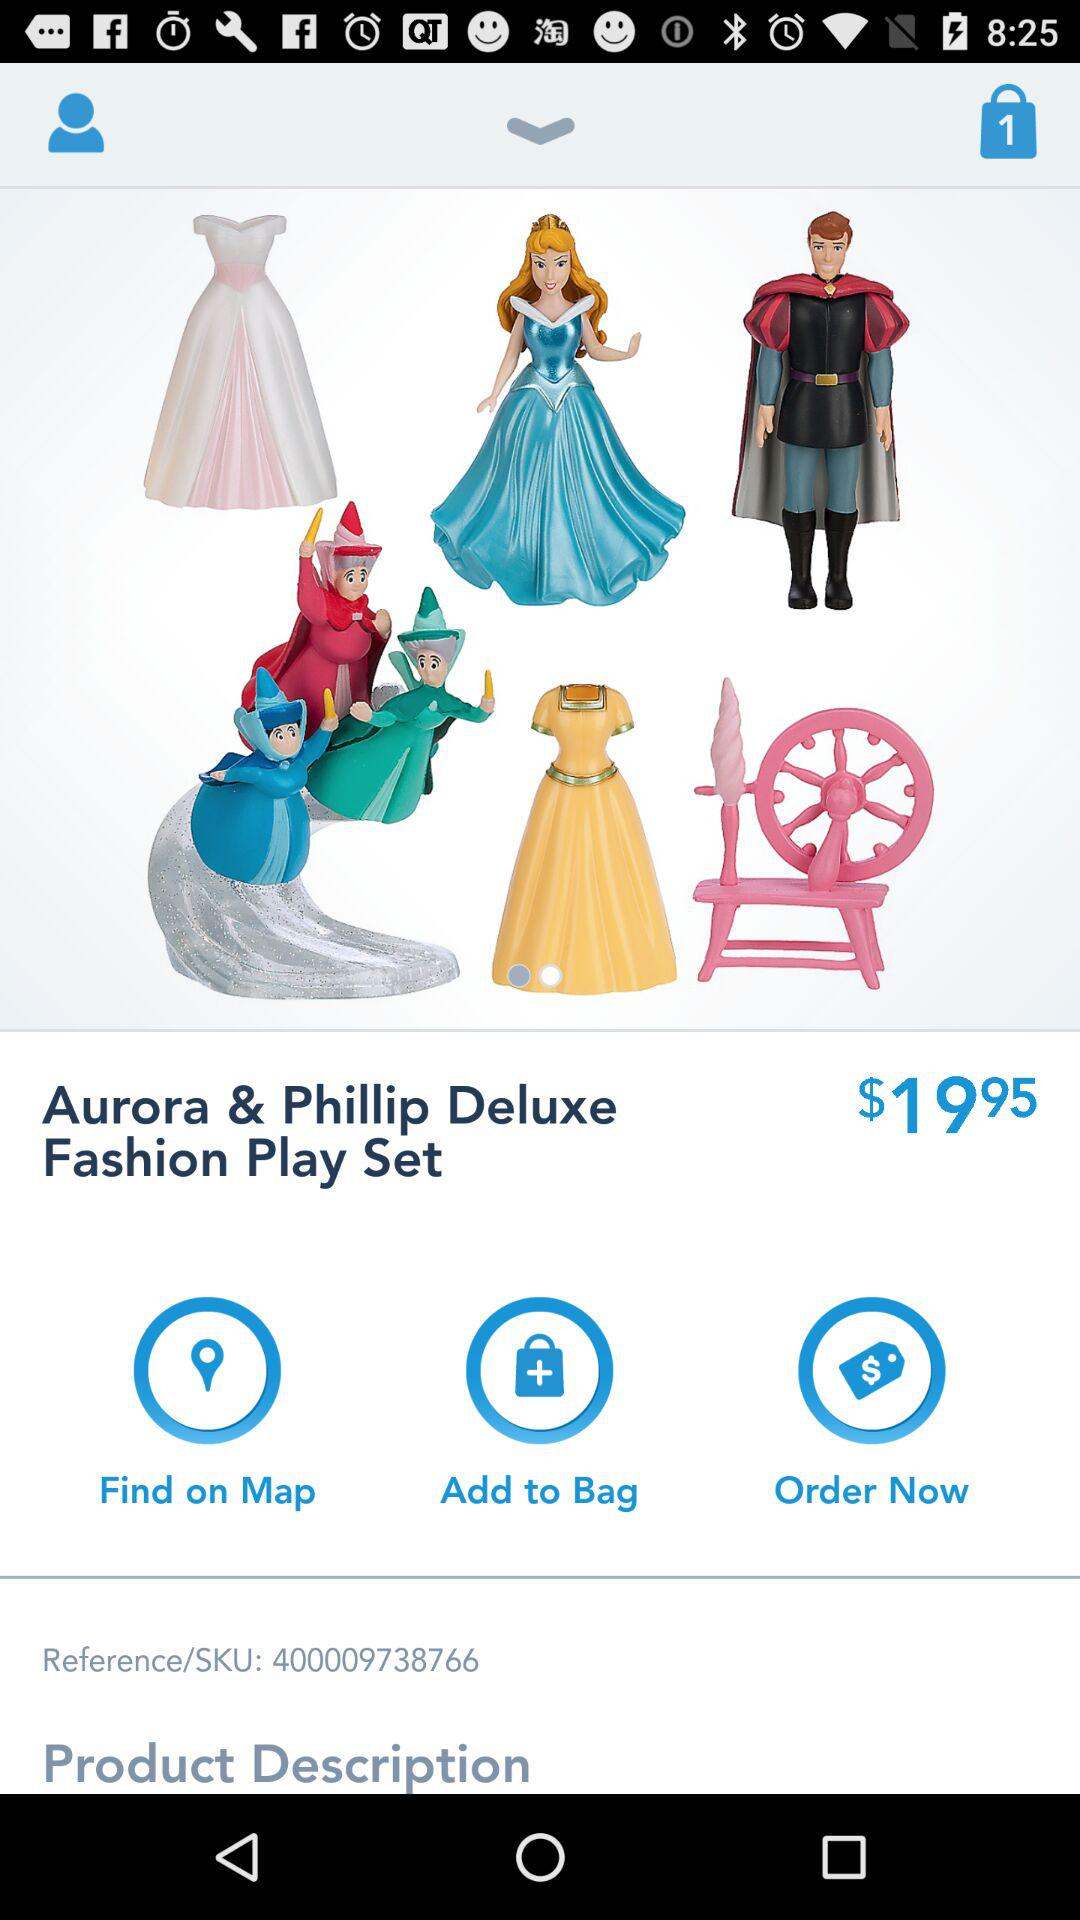How many items are in the bag? There is 1 item in the bag. 